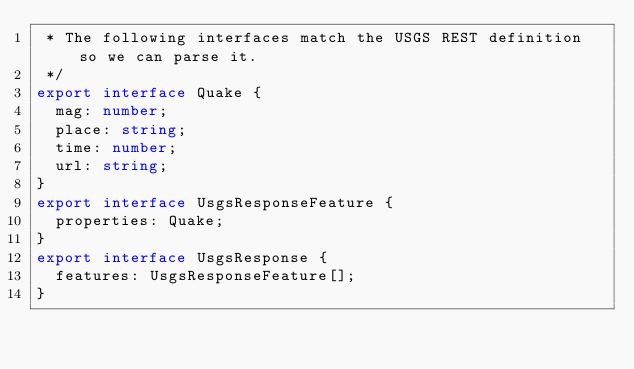<code> <loc_0><loc_0><loc_500><loc_500><_TypeScript_> * The following interfaces match the USGS REST definition so we can parse it.
 */
export interface Quake {
  mag: number;
  place: string;
  time: number;
  url: string;
}
export interface UsgsResponseFeature {
  properties: Quake;
}
export interface UsgsResponse {
  features: UsgsResponseFeature[];
}

</code> 